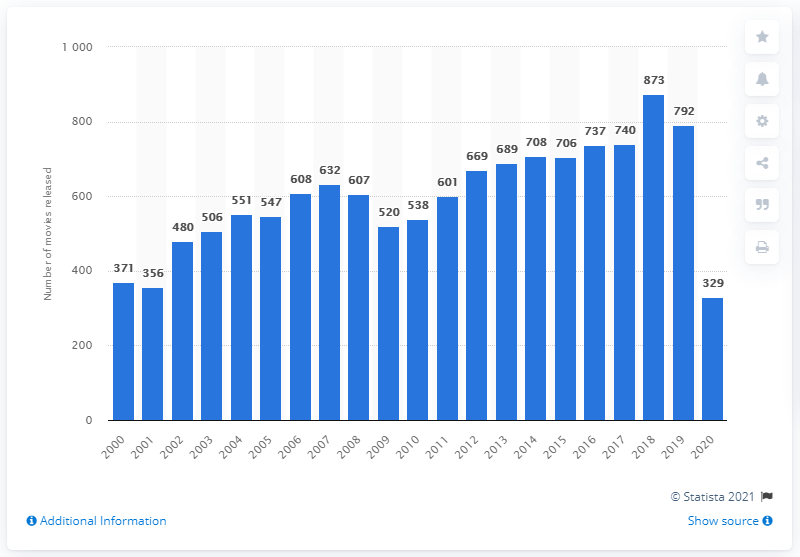Indicate a few pertinent items in this graphic. In the United States and Canada in 2020, 329 movies were released. 